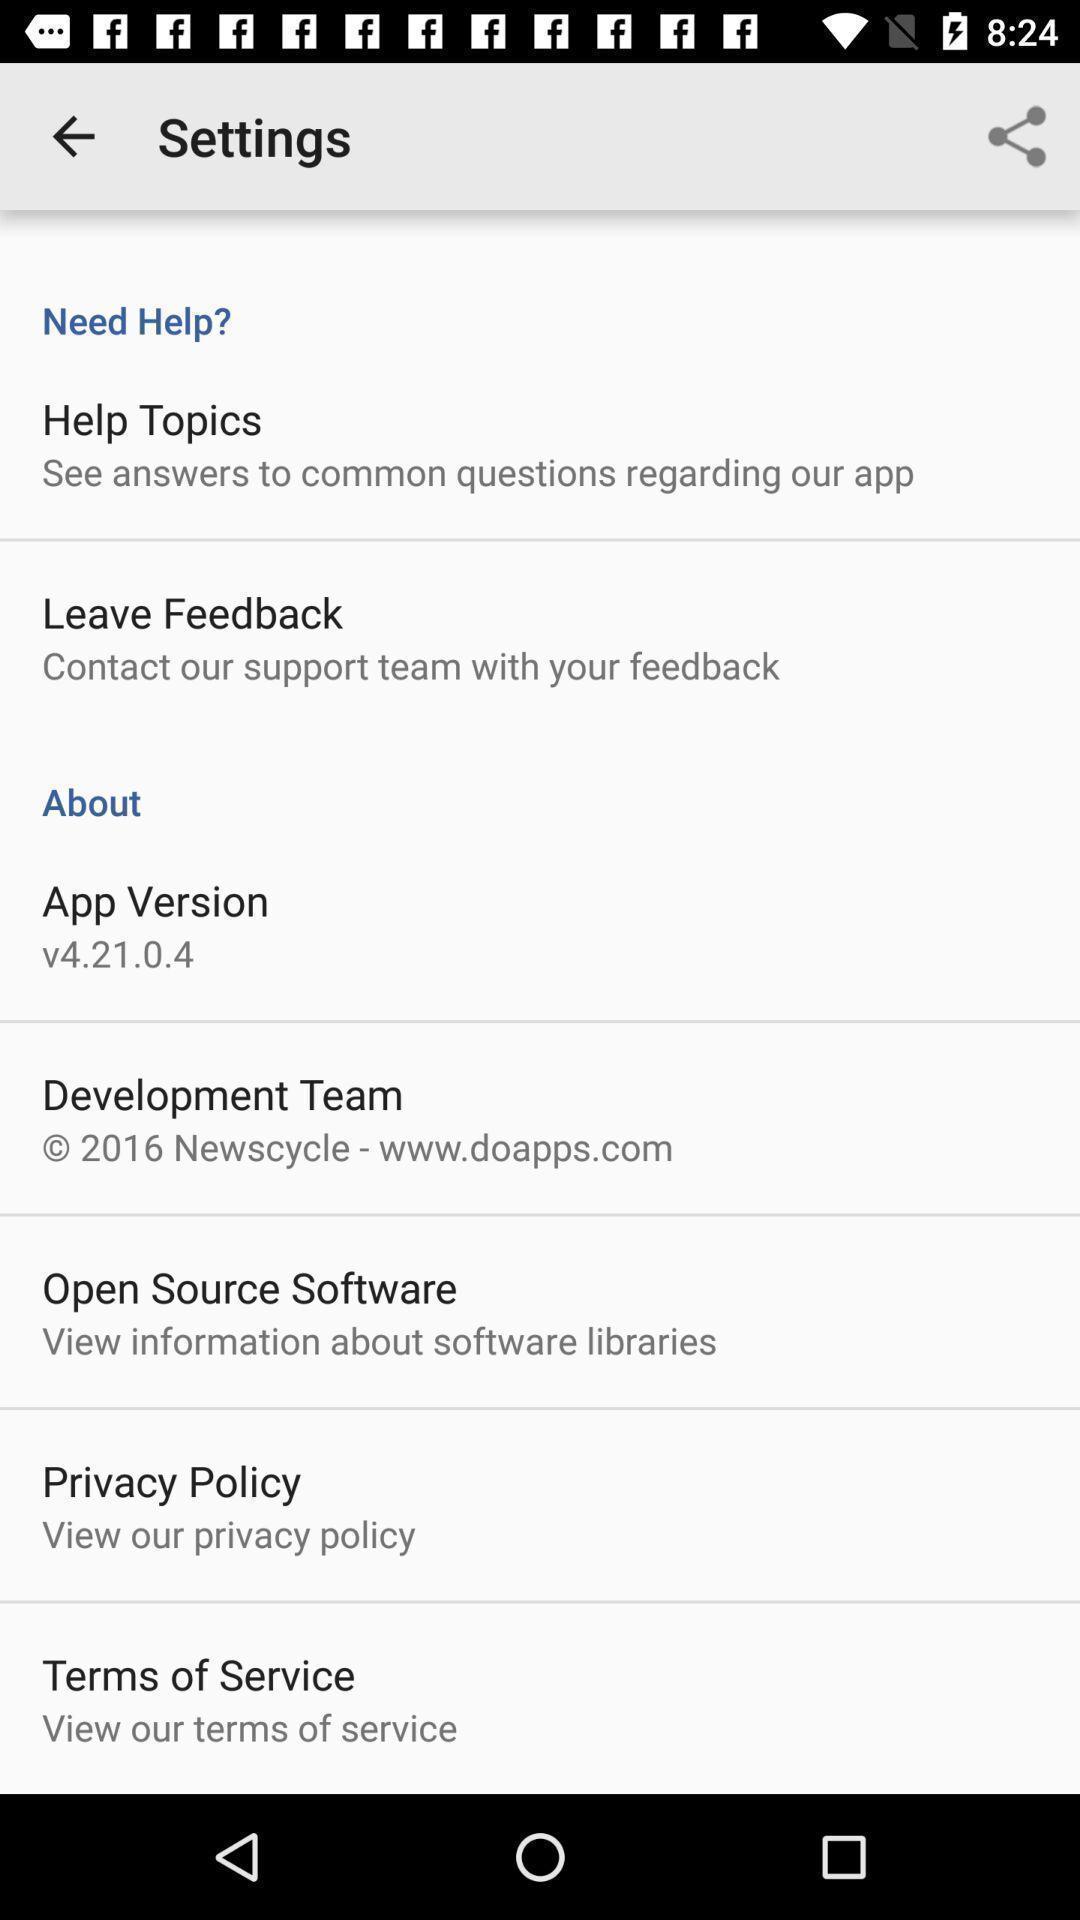Provide a detailed account of this screenshot. Settings page in a local app. 